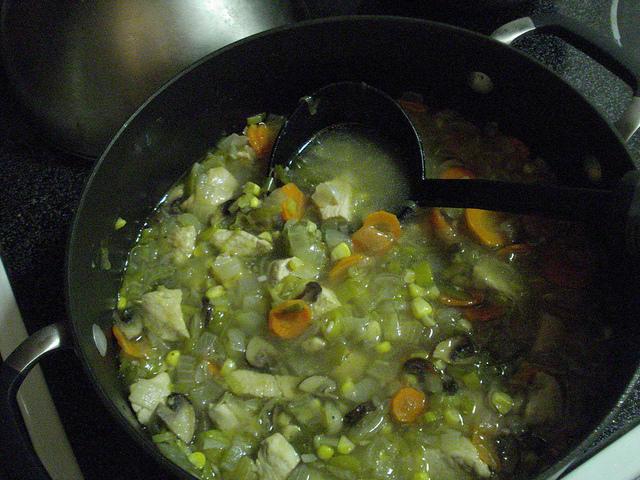What vegetable is in the photo?
Quick response, please. Carrot. What color is the pot?
Answer briefly. Black. Is this a consomme?
Quick response, please. No. What is cooking on the pan?
Keep it brief. Soup. Are there any vegetables in the pot?
Concise answer only. Yes. What are these?
Write a very short answer. Vegetables. 